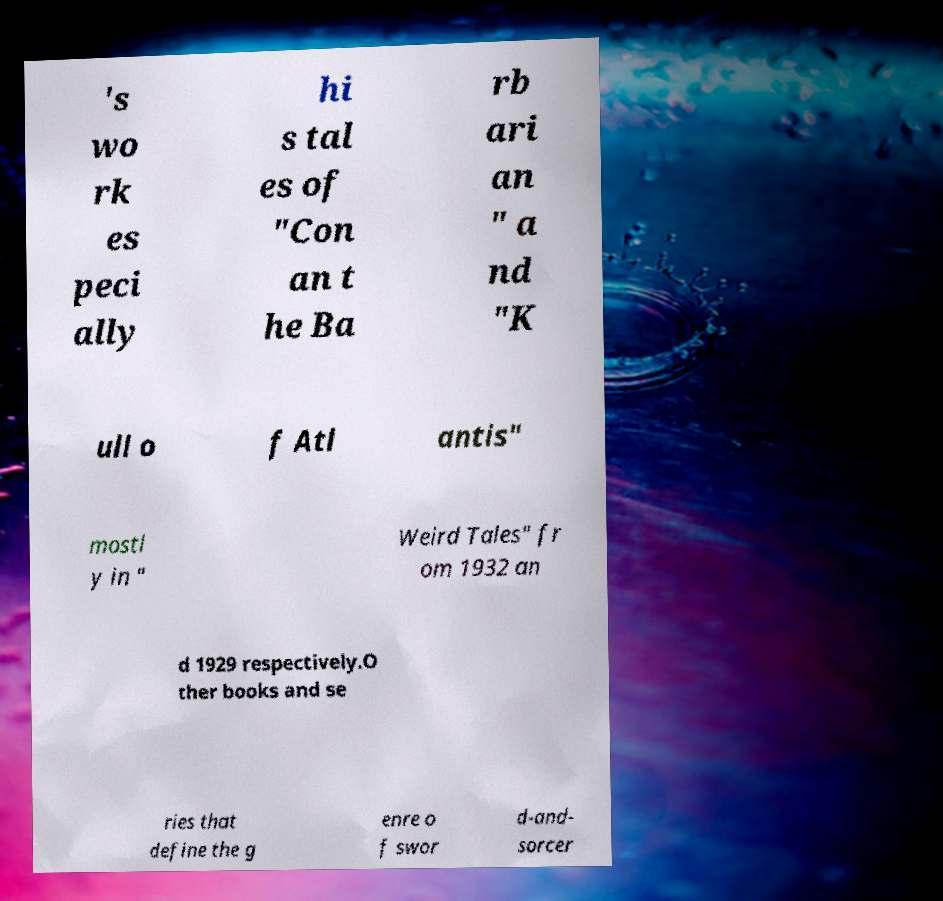What messages or text are displayed in this image? I need them in a readable, typed format. 's wo rk es peci ally hi s tal es of "Con an t he Ba rb ari an " a nd "K ull o f Atl antis" mostl y in " Weird Tales" fr om 1932 an d 1929 respectively.O ther books and se ries that define the g enre o f swor d-and- sorcer 